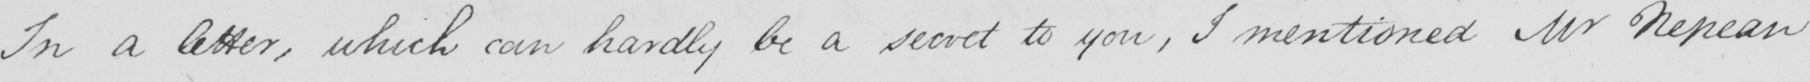Transcribe the text shown in this historical manuscript line. In a letter , which can hardly be a secret to you , I mentioned Mr Nepean 